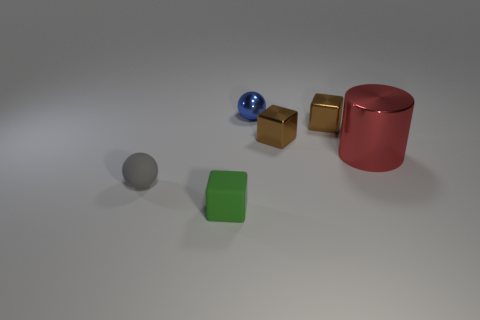Are there the same number of small blue shiny objects left of the green cube and big brown spheres?
Provide a succinct answer. Yes. Is there any other thing that is the same size as the red shiny cylinder?
Ensure brevity in your answer.  No. What material is the small gray object that is the same shape as the tiny blue thing?
Offer a terse response. Rubber. What is the shape of the tiny matte object behind the object that is in front of the tiny matte ball?
Offer a terse response. Sphere. Do the tiny sphere that is in front of the large red cylinder and the tiny green block have the same material?
Provide a short and direct response. Yes. Is the number of green matte cubes that are behind the green thing the same as the number of brown things behind the large metallic cylinder?
Your response must be concise. No. There is a cube that is in front of the large metallic thing; what number of cylinders are on the left side of it?
Your answer should be very brief. 0. There is another blue sphere that is the same size as the matte ball; what is its material?
Give a very brief answer. Metal. The object in front of the rubber thing that is to the left of the matte object right of the small gray object is what shape?
Offer a very short reply. Cube. There is a blue shiny object that is the same size as the green matte block; what is its shape?
Ensure brevity in your answer.  Sphere. 